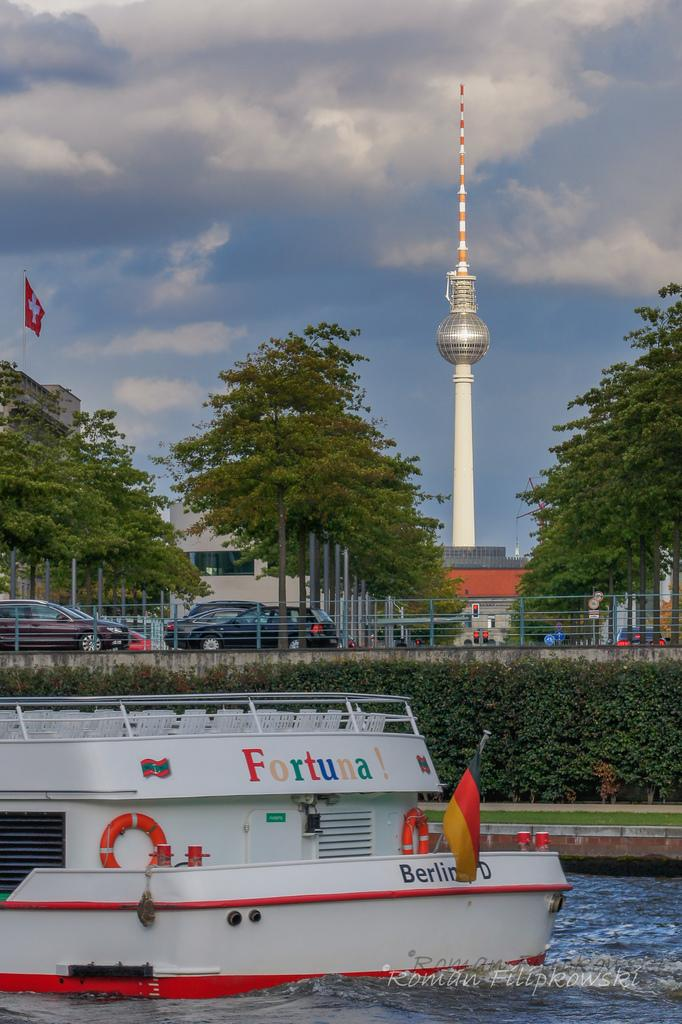<image>
Present a compact description of the photo's key features. A boat with the name Fortuna! writtne in rainbow colors 